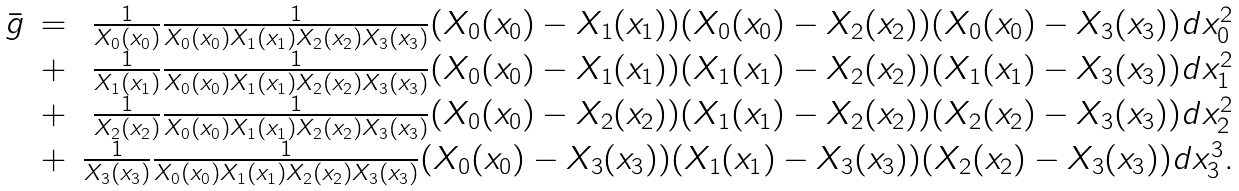Convert formula to latex. <formula><loc_0><loc_0><loc_500><loc_500>\begin{array} { c c r } \bar { g } & = & \frac { 1 } { X _ { 0 } ( x _ { 0 } ) } \frac { 1 } { X _ { 0 } ( x _ { 0 } ) X _ { 1 } ( x _ { 1 } ) X _ { 2 } ( x _ { 2 } ) X _ { 3 } ( x _ { 3 } ) } ( X _ { 0 } ( x _ { 0 } ) - X _ { 1 } ( x _ { 1 } ) ) ( X _ { 0 } ( x _ { 0 } ) - X _ { 2 } ( x _ { 2 } ) ) ( X _ { 0 } ( x _ { 0 } ) - X _ { 3 } ( x _ { 3 } ) ) d x _ { 0 } ^ { 2 } \\ & + & \frac { 1 } { X _ { 1 } ( x _ { 1 } ) } \frac { 1 } { X _ { 0 } ( x _ { 0 } ) X _ { 1 } ( x _ { 1 } ) X _ { 2 } ( x _ { 2 } ) X _ { 3 } ( x _ { 3 } ) } ( X _ { 0 } ( x _ { 0 } ) - X _ { 1 } ( x _ { 1 } ) ) ( X _ { 1 } ( x _ { 1 } ) - X _ { 2 } ( x _ { 2 } ) ) ( X _ { 1 } ( x _ { 1 } ) - X _ { 3 } ( x _ { 3 } ) ) d x _ { 1 } ^ { 2 } \\ & + & \frac { 1 } { X _ { 2 } ( x _ { 2 } ) } \frac { 1 } { X _ { 0 } ( x _ { 0 } ) X _ { 1 } ( x _ { 1 } ) X _ { 2 } ( x _ { 2 } ) X _ { 3 } ( x _ { 3 } ) } ( X _ { 0 } ( x _ { 0 } ) - X _ { 2 } ( x _ { 2 } ) ) ( X _ { 1 } ( x _ { 1 } ) - X _ { 2 } ( x _ { 2 } ) ) ( X _ { 2 } ( x _ { 2 } ) - X _ { 3 } ( x _ { 3 } ) ) d x _ { 2 } ^ { 2 } \\ & + & \frac { 1 } { X _ { 3 } ( x _ { 3 } ) } \frac { 1 } { X _ { 0 } ( x _ { 0 } ) X _ { 1 } ( x _ { 1 } ) X _ { 2 } ( x _ { 2 } ) X _ { 3 } ( x _ { 3 } ) } ( X _ { 0 } ( x _ { 0 } ) - X _ { 3 } ( x _ { 3 } ) ) ( X _ { 1 } ( x _ { 1 } ) - X _ { 3 } ( x _ { 3 } ) ) ( X _ { 2 } ( x _ { 2 } ) - X _ { 3 } ( x _ { 3 } ) ) d x _ { 3 } ^ { 3 } . \end{array}</formula> 